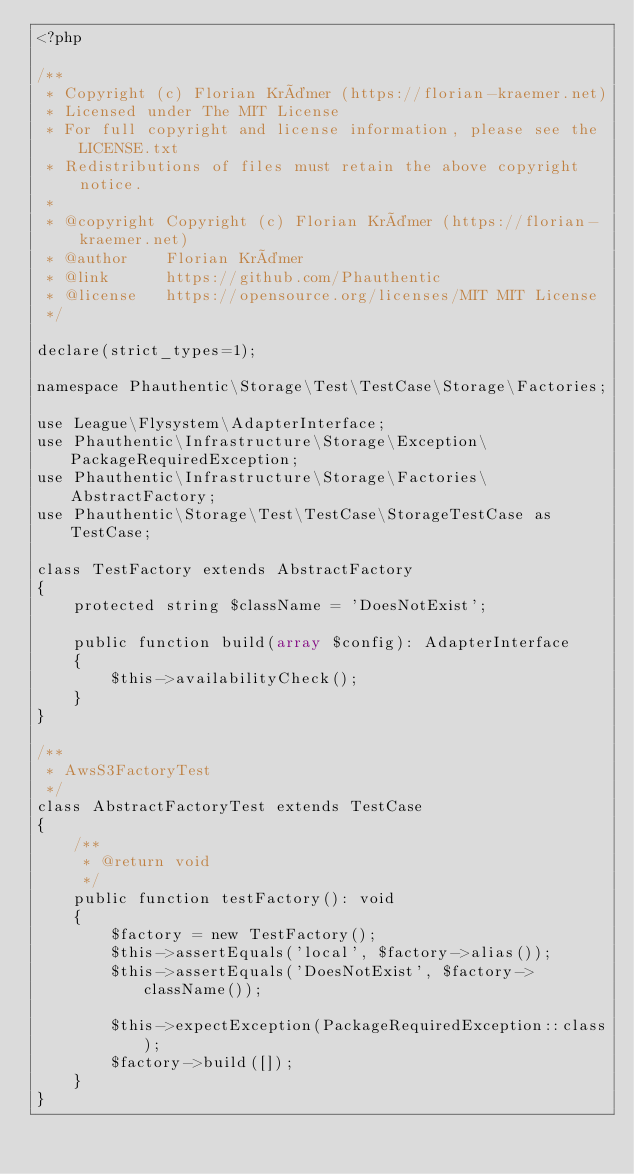Convert code to text. <code><loc_0><loc_0><loc_500><loc_500><_PHP_><?php

/**
 * Copyright (c) Florian Krämer (https://florian-kraemer.net)
 * Licensed under The MIT License
 * For full copyright and license information, please see the LICENSE.txt
 * Redistributions of files must retain the above copyright notice.
 *
 * @copyright Copyright (c) Florian Krämer (https://florian-kraemer.net)
 * @author    Florian Krämer
 * @link      https://github.com/Phauthentic
 * @license   https://opensource.org/licenses/MIT MIT License
 */

declare(strict_types=1);

namespace Phauthentic\Storage\Test\TestCase\Storage\Factories;

use League\Flysystem\AdapterInterface;
use Phauthentic\Infrastructure\Storage\Exception\PackageRequiredException;
use Phauthentic\Infrastructure\Storage\Factories\AbstractFactory;
use Phauthentic\Storage\Test\TestCase\StorageTestCase as TestCase;

class TestFactory extends AbstractFactory
{
    protected string $className = 'DoesNotExist';

    public function build(array $config): AdapterInterface
    {
        $this->availabilityCheck();
    }
}

/**
 * AwsS3FactoryTest
 */
class AbstractFactoryTest extends TestCase
{
    /**
     * @return void
     */
    public function testFactory(): void
    {
        $factory = new TestFactory();
        $this->assertEquals('local', $factory->alias());
        $this->assertEquals('DoesNotExist', $factory->className());

        $this->expectException(PackageRequiredException::class);
        $factory->build([]);
    }
}
</code> 